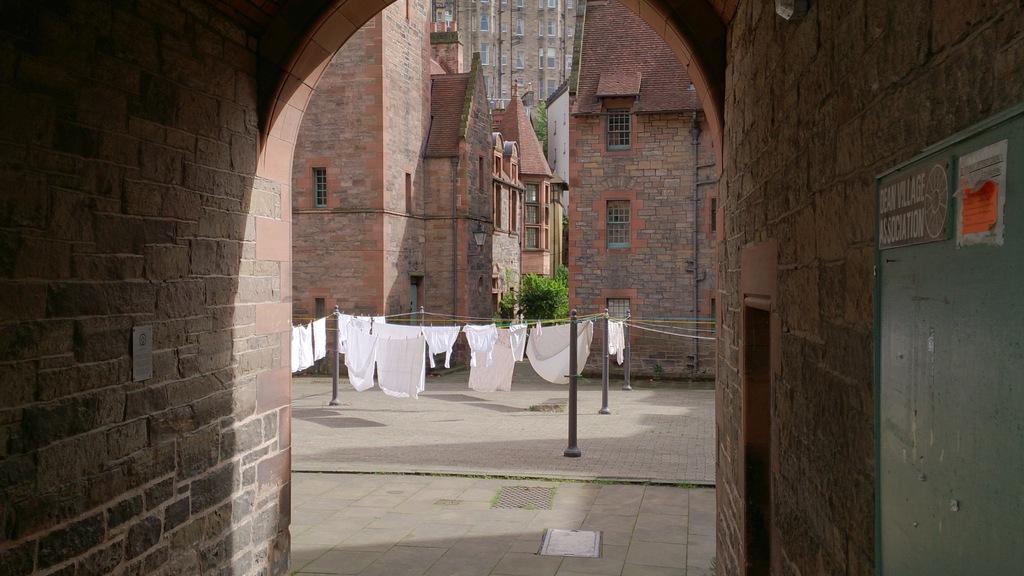Please provide a concise description of this image. This picture shows few buildings and trees and we see clothes on the ropes and few poles and we see a board to the wall. 